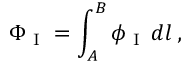<formula> <loc_0><loc_0><loc_500><loc_500>\Phi _ { I } = \int _ { A } ^ { B } \phi _ { I } \, d l \, ,</formula> 